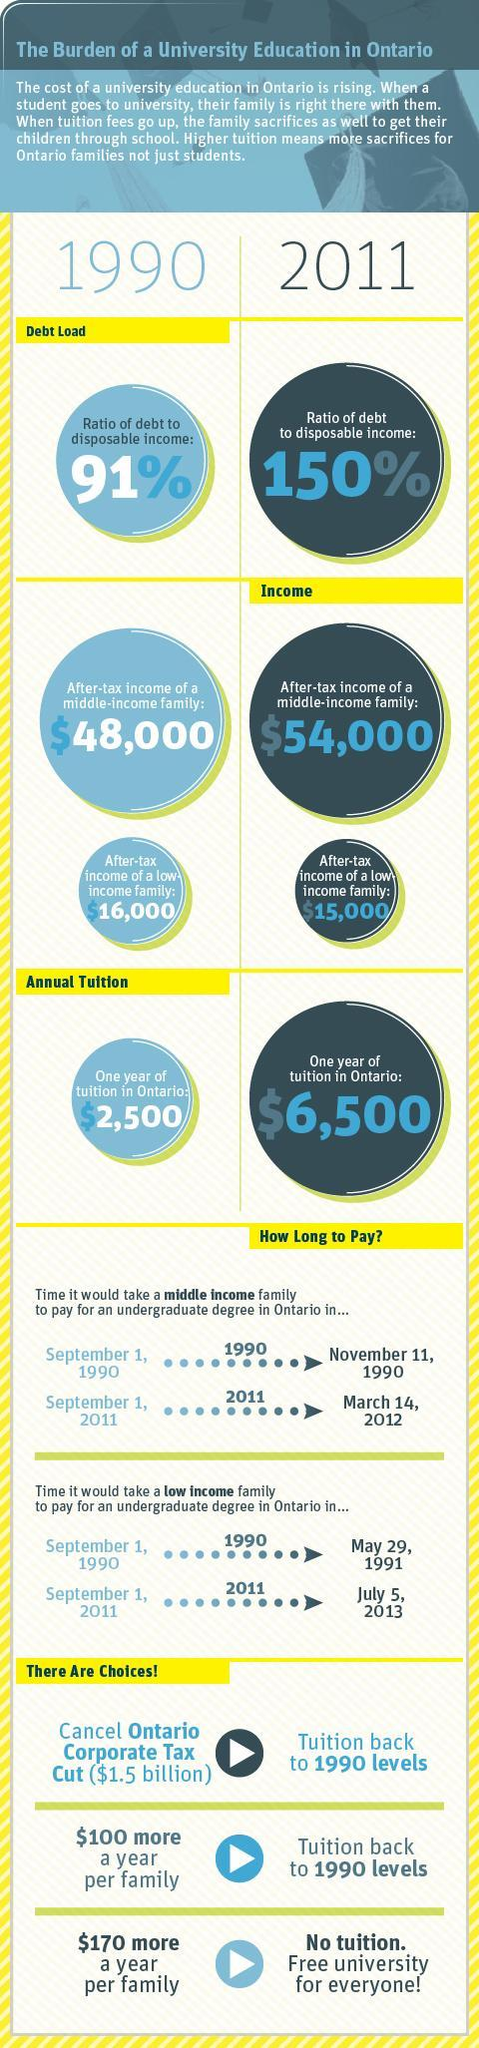In 2011, when would a middle income family in Ontario, finish paying for an undergraduate degree?
Answer the question with a short phrase. March 14, 2012 What was the after tax income of a middle income family in 1990? $48,000 How much has the annual tuition fee in Ontario increased over the past 21 years($)? 4000 What is Ontario's corporate tax deduction($)? 1.5 billion Which of the 3 choices allows free university for everyone? $170 more a year per family What was the per annum tuition fee in Ontario in 2011? $6,500 What was the after tax income of a middle income family in 2011? $54,000 How much was the after-tax income of a middle income family higher than that of a low income family in 1990($)? 32000 In which year, was the ratio of debt to disposable income lower? 1990 How many choices are mentioned, to bring down the tuition? 3 What is the ratio of debt to disposable income in 2011? 150% By how much should the income of a family in Ontario be increased to bring back the tuition fee to 1990 level? $100 What is the decrease in the after-tax income of a low income family over the 21 years($)? 1000 What was the one year tuition fee in Ontario in 1990? $2,500 